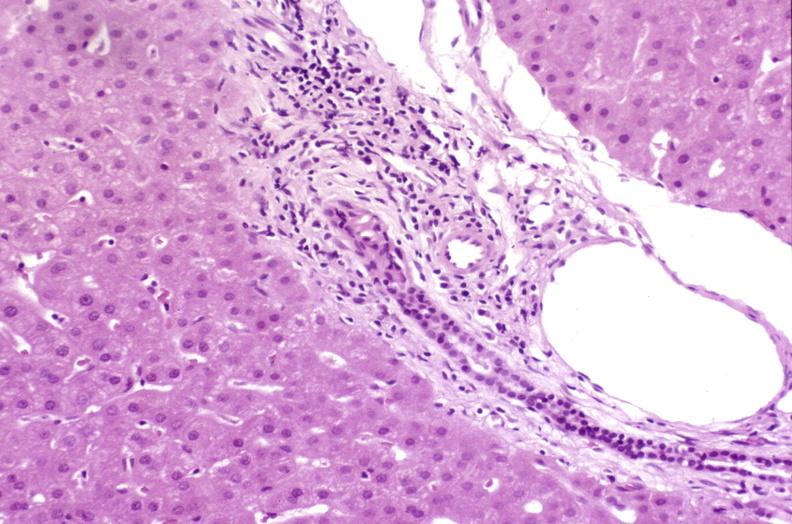does alpha smooth muscle actin immunohistochemical show resolving acute rejection?
Answer the question using a single word or phrase. No 